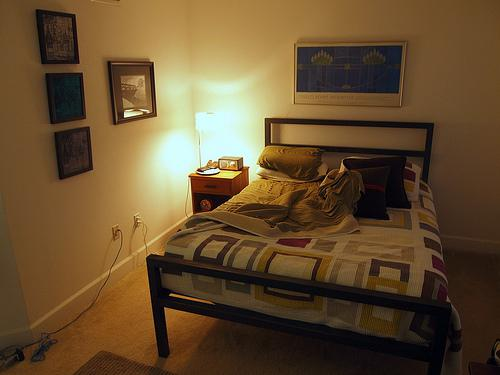Question: what is this a picture of?
Choices:
A. Bedroom.
B. Kitchen.
C. Living room.
D. Dining room.
Answer with the letter. Answer: A Question: how many picture are on the wall?
Choices:
A. 4.
B. 6.
C. 3.
D. 5.
Answer with the letter. Answer: D Question: what is beside the bed?
Choices:
A. A lamp.
B. A basket.
C. A nightstand.
D. A dresser.
Answer with the letter. Answer: C Question: how are the sheets?
Choices:
A. On the bed.
B. Rolled up.
C. Folded up.
D. Folded back.
Answer with the letter. Answer: D Question: where is the nightstand?
Choices:
A. On the floor.
B. Next to the door.
C. Beside bed.
D. Next to the dresser.
Answer with the letter. Answer: C Question: how many wall plugs are there?
Choices:
A. 1.
B. 3.
C. 4.
D. 2.
Answer with the letter. Answer: D 